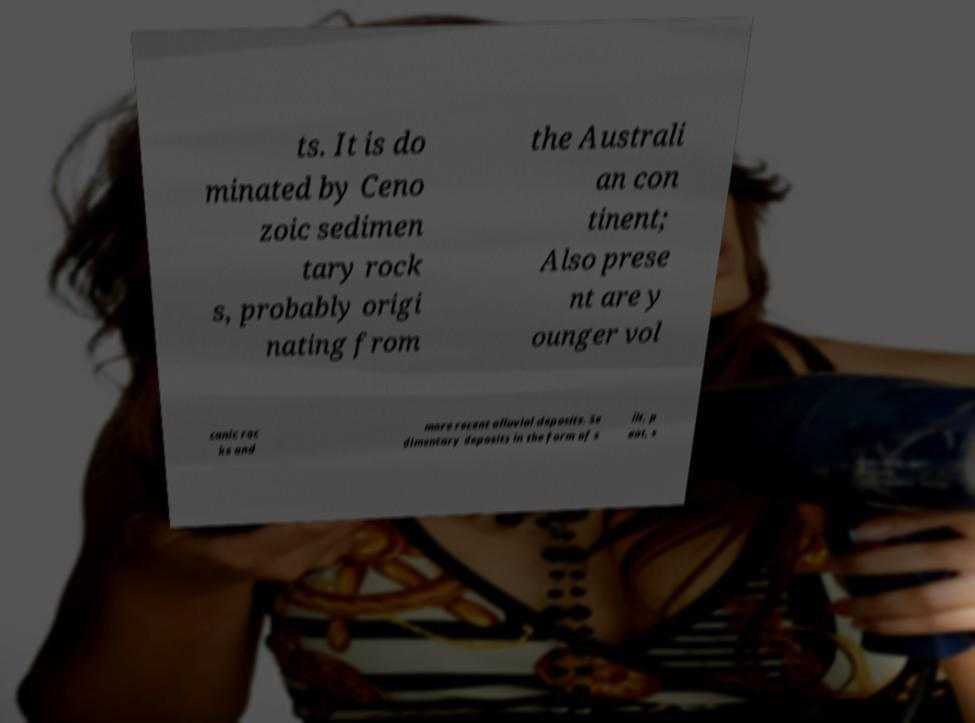I need the written content from this picture converted into text. Can you do that? ts. It is do minated by Ceno zoic sedimen tary rock s, probably origi nating from the Australi an con tinent; Also prese nt are y ounger vol canic roc ks and more recent alluvial deposits. Se dimentary deposits in the form of s ilt, p eat, s 